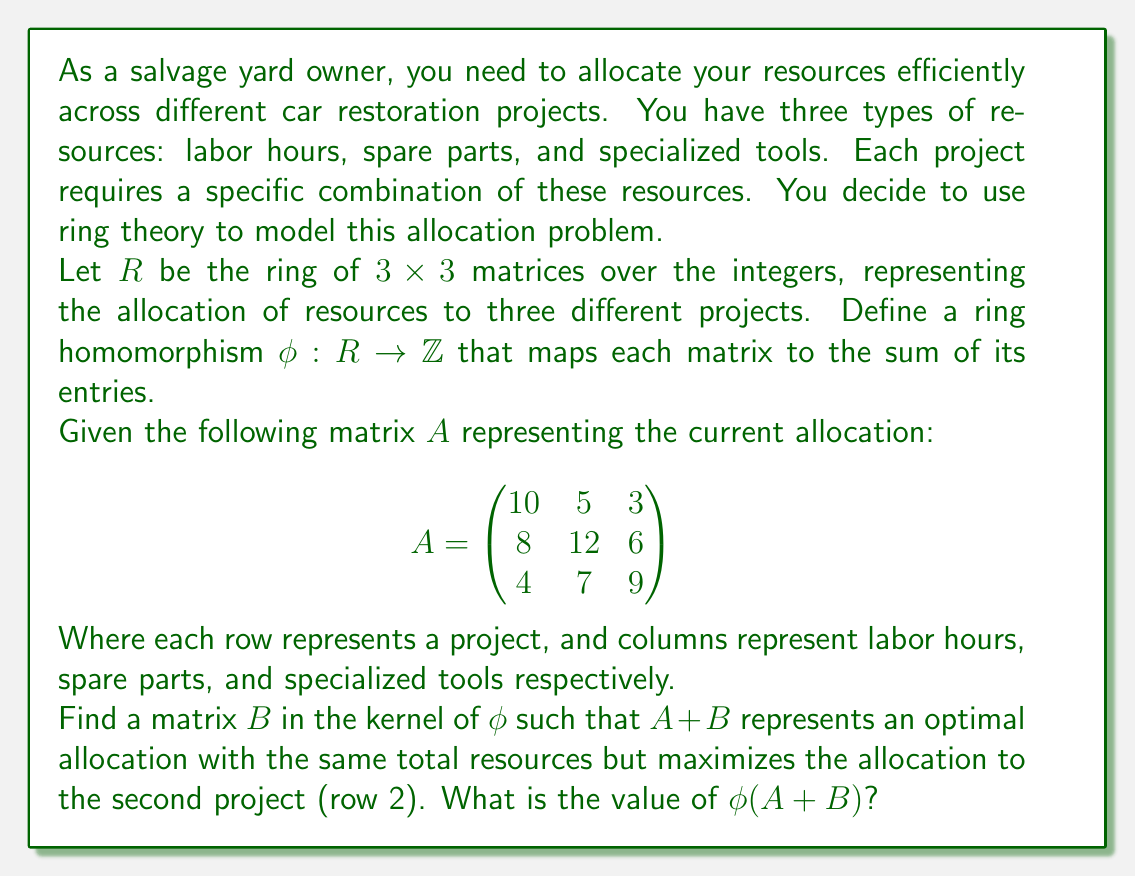Teach me how to tackle this problem. Let's approach this step-by-step:

1) First, recall that the kernel of a ring homomorphism $\phi$ is the set of all elements that map to zero. In this case:

   $\text{ker}(\phi) = \{X \in R : \phi(X) = 0\}$

2) For a $3 \times 3$ matrix $X$, $\phi(X) = 0$ means the sum of all entries in $X$ is zero.

3) We want to find a matrix $B$ in the kernel of $\phi$ such that when added to $A$, it increases the values in the second row while decreasing others, keeping the total sum constant.

4) One possible matrix $B$ that satisfies these conditions is:

   $$B = \begin{pmatrix}
   -2 & -1 & -1 \\
   3 & 2 & 2 \\
   -1 & -1 & -1
   \end{pmatrix}$$

5) We can verify that $B$ is in the kernel of $\phi$:

   $\phi(B) = (-2-1-1) + (3+2+2) + (-1-1-1) = -4 + 7 - 3 = 0$

6) Now, let's calculate $A + B$:

   $$A + B = \begin{pmatrix}
   10 & 5 & 3 \\
   8 & 12 & 6 \\
   4 & 7 & 9
   \end{pmatrix} + 
   \begin{pmatrix}
   -2 & -1 & -1 \\
   3 & 2 & 2 \\
   -1 & -1 & -1
   \end{pmatrix} = 
   \begin{pmatrix}
   8 & 4 & 2 \\
   11 & 14 & 8 \\
   3 & 6 & 8
   \end{pmatrix}$$

7) We can see that the second row (project) has increased its allocation, while the others have decreased, maintaining the same total.

8) To find $\phi(A + B)$, we sum all entries of the resulting matrix:

   $\phi(A + B) = (8+4+2) + (11+14+8) + (3+6+8) = 14 + 33 + 17 = 64$

This is the same as $\phi(A)$, confirming that we've maintained the total resources while optimizing the allocation for the second project.
Answer: $\phi(A + B) = 64$ 